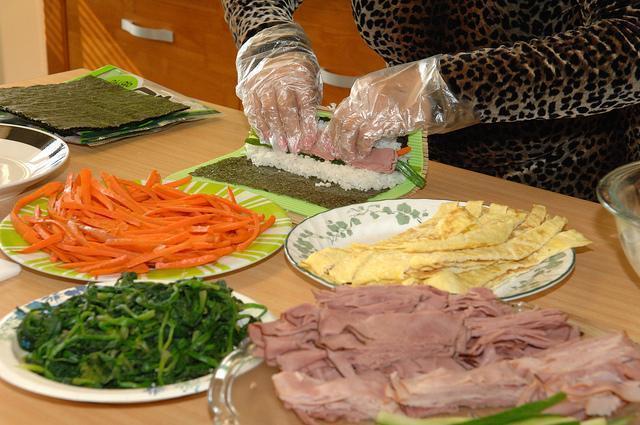What dish is the person assembling these food items to mimic?
Select the accurate response from the four choices given to answer the question.
Options: Sushi, burritos, tacos, pizza. Sushi. 